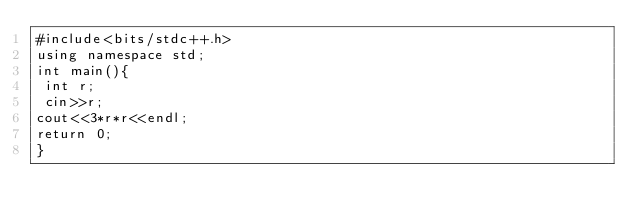Convert code to text. <code><loc_0><loc_0><loc_500><loc_500><_C++_>#include<bits/stdc++.h>
using namespace std;
int main(){
 int r;
 cin>>r;
cout<<3*r*r<<endl;
return 0;
}</code> 